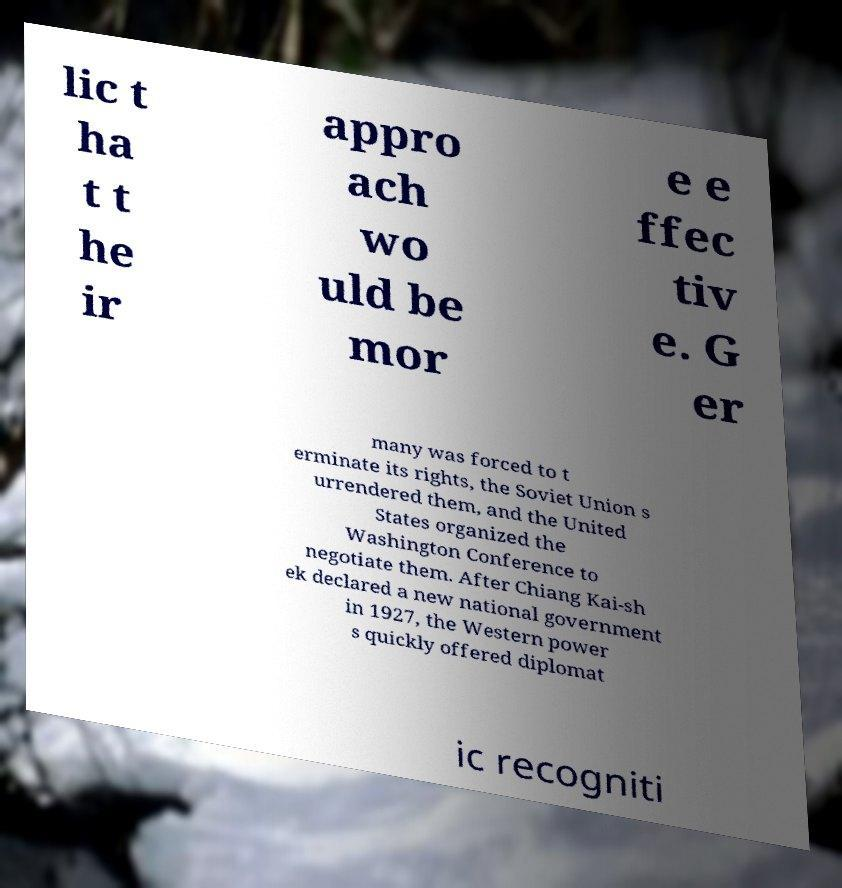Can you read and provide the text displayed in the image?This photo seems to have some interesting text. Can you extract and type it out for me? lic t ha t t he ir appro ach wo uld be mor e e ffec tiv e. G er many was forced to t erminate its rights, the Soviet Union s urrendered them, and the United States organized the Washington Conference to negotiate them. After Chiang Kai-sh ek declared a new national government in 1927, the Western power s quickly offered diplomat ic recogniti 